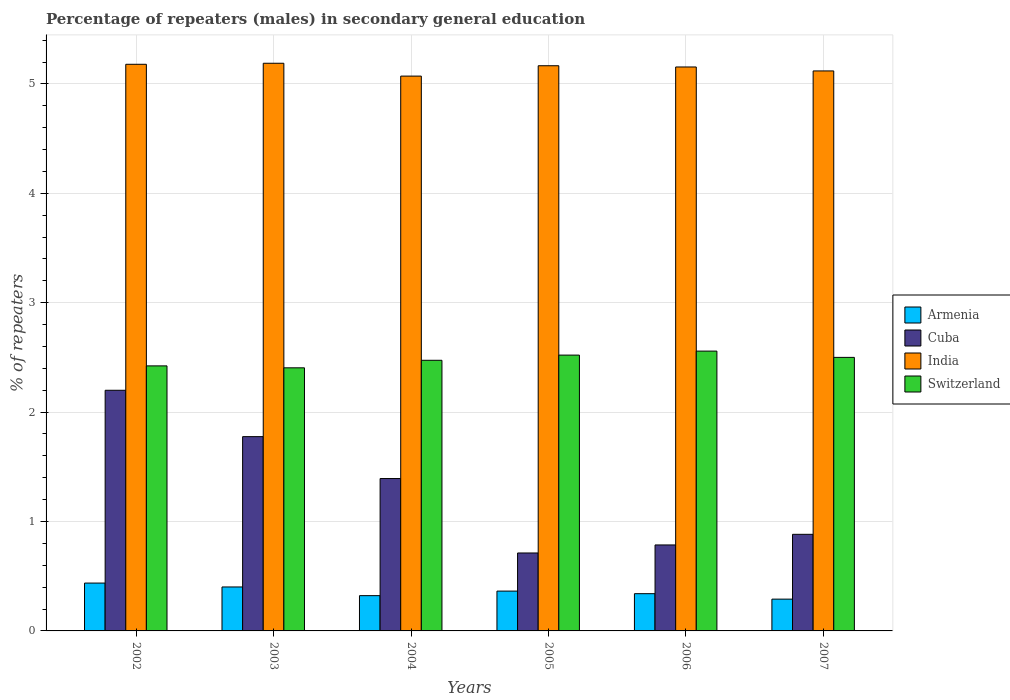Are the number of bars per tick equal to the number of legend labels?
Make the answer very short. Yes. How many bars are there on the 4th tick from the left?
Provide a succinct answer. 4. How many bars are there on the 3rd tick from the right?
Keep it short and to the point. 4. What is the label of the 2nd group of bars from the left?
Provide a short and direct response. 2003. In how many cases, is the number of bars for a given year not equal to the number of legend labels?
Your answer should be compact. 0. What is the percentage of male repeaters in India in 2004?
Keep it short and to the point. 5.07. Across all years, what is the maximum percentage of male repeaters in India?
Offer a terse response. 5.19. Across all years, what is the minimum percentage of male repeaters in Armenia?
Your answer should be compact. 0.29. In which year was the percentage of male repeaters in Cuba maximum?
Your answer should be compact. 2002. What is the total percentage of male repeaters in India in the graph?
Keep it short and to the point. 30.88. What is the difference between the percentage of male repeaters in India in 2002 and that in 2004?
Provide a succinct answer. 0.11. What is the difference between the percentage of male repeaters in India in 2003 and the percentage of male repeaters in Armenia in 2002?
Provide a succinct answer. 4.75. What is the average percentage of male repeaters in Cuba per year?
Provide a succinct answer. 1.29. In the year 2003, what is the difference between the percentage of male repeaters in Cuba and percentage of male repeaters in India?
Provide a succinct answer. -3.41. In how many years, is the percentage of male repeaters in Switzerland greater than 4.6 %?
Your answer should be compact. 0. What is the ratio of the percentage of male repeaters in Switzerland in 2005 to that in 2007?
Provide a succinct answer. 1.01. What is the difference between the highest and the second highest percentage of male repeaters in Armenia?
Your answer should be very brief. 0.04. What is the difference between the highest and the lowest percentage of male repeaters in India?
Your response must be concise. 0.12. Is the sum of the percentage of male repeaters in Cuba in 2004 and 2005 greater than the maximum percentage of male repeaters in India across all years?
Offer a very short reply. No. Is it the case that in every year, the sum of the percentage of male repeaters in Armenia and percentage of male repeaters in Switzerland is greater than the sum of percentage of male repeaters in India and percentage of male repeaters in Cuba?
Make the answer very short. No. What does the 2nd bar from the left in 2004 represents?
Your answer should be compact. Cuba. What does the 2nd bar from the right in 2002 represents?
Offer a terse response. India. How many bars are there?
Your answer should be very brief. 24. Are all the bars in the graph horizontal?
Your answer should be very brief. No. How many years are there in the graph?
Your answer should be very brief. 6. Does the graph contain any zero values?
Your answer should be compact. No. Does the graph contain grids?
Keep it short and to the point. Yes. How many legend labels are there?
Provide a succinct answer. 4. What is the title of the graph?
Offer a very short reply. Percentage of repeaters (males) in secondary general education. Does "Tunisia" appear as one of the legend labels in the graph?
Provide a short and direct response. No. What is the label or title of the X-axis?
Your response must be concise. Years. What is the label or title of the Y-axis?
Your answer should be very brief. % of repeaters. What is the % of repeaters in Armenia in 2002?
Keep it short and to the point. 0.44. What is the % of repeaters in Cuba in 2002?
Provide a short and direct response. 2.2. What is the % of repeaters of India in 2002?
Provide a succinct answer. 5.18. What is the % of repeaters in Switzerland in 2002?
Your answer should be compact. 2.42. What is the % of repeaters of Armenia in 2003?
Give a very brief answer. 0.4. What is the % of repeaters of Cuba in 2003?
Your response must be concise. 1.78. What is the % of repeaters of India in 2003?
Offer a terse response. 5.19. What is the % of repeaters of Switzerland in 2003?
Make the answer very short. 2.4. What is the % of repeaters in Armenia in 2004?
Make the answer very short. 0.32. What is the % of repeaters in Cuba in 2004?
Offer a terse response. 1.39. What is the % of repeaters of India in 2004?
Provide a succinct answer. 5.07. What is the % of repeaters in Switzerland in 2004?
Give a very brief answer. 2.47. What is the % of repeaters in Armenia in 2005?
Your answer should be very brief. 0.36. What is the % of repeaters of Cuba in 2005?
Give a very brief answer. 0.71. What is the % of repeaters in India in 2005?
Keep it short and to the point. 5.17. What is the % of repeaters in Switzerland in 2005?
Keep it short and to the point. 2.52. What is the % of repeaters in Armenia in 2006?
Your answer should be compact. 0.34. What is the % of repeaters in Cuba in 2006?
Ensure brevity in your answer.  0.79. What is the % of repeaters of India in 2006?
Your answer should be compact. 5.15. What is the % of repeaters in Switzerland in 2006?
Your answer should be compact. 2.56. What is the % of repeaters in Armenia in 2007?
Offer a very short reply. 0.29. What is the % of repeaters in Cuba in 2007?
Your answer should be very brief. 0.88. What is the % of repeaters in India in 2007?
Your answer should be very brief. 5.12. What is the % of repeaters of Switzerland in 2007?
Your answer should be compact. 2.5. Across all years, what is the maximum % of repeaters of Armenia?
Offer a very short reply. 0.44. Across all years, what is the maximum % of repeaters of Cuba?
Offer a very short reply. 2.2. Across all years, what is the maximum % of repeaters of India?
Your response must be concise. 5.19. Across all years, what is the maximum % of repeaters of Switzerland?
Give a very brief answer. 2.56. Across all years, what is the minimum % of repeaters in Armenia?
Offer a terse response. 0.29. Across all years, what is the minimum % of repeaters in Cuba?
Keep it short and to the point. 0.71. Across all years, what is the minimum % of repeaters in India?
Your response must be concise. 5.07. Across all years, what is the minimum % of repeaters of Switzerland?
Your response must be concise. 2.4. What is the total % of repeaters in Armenia in the graph?
Your response must be concise. 2.16. What is the total % of repeaters of Cuba in the graph?
Provide a succinct answer. 7.75. What is the total % of repeaters of India in the graph?
Offer a terse response. 30.88. What is the total % of repeaters in Switzerland in the graph?
Your answer should be compact. 14.88. What is the difference between the % of repeaters of Armenia in 2002 and that in 2003?
Provide a short and direct response. 0.04. What is the difference between the % of repeaters of Cuba in 2002 and that in 2003?
Your answer should be compact. 0.42. What is the difference between the % of repeaters in India in 2002 and that in 2003?
Offer a terse response. -0.01. What is the difference between the % of repeaters in Switzerland in 2002 and that in 2003?
Offer a terse response. 0.02. What is the difference between the % of repeaters in Armenia in 2002 and that in 2004?
Your answer should be compact. 0.11. What is the difference between the % of repeaters in Cuba in 2002 and that in 2004?
Ensure brevity in your answer.  0.81. What is the difference between the % of repeaters of India in 2002 and that in 2004?
Ensure brevity in your answer.  0.11. What is the difference between the % of repeaters in Switzerland in 2002 and that in 2004?
Make the answer very short. -0.05. What is the difference between the % of repeaters in Armenia in 2002 and that in 2005?
Keep it short and to the point. 0.07. What is the difference between the % of repeaters in Cuba in 2002 and that in 2005?
Give a very brief answer. 1.49. What is the difference between the % of repeaters in India in 2002 and that in 2005?
Provide a short and direct response. 0.01. What is the difference between the % of repeaters of Switzerland in 2002 and that in 2005?
Ensure brevity in your answer.  -0.1. What is the difference between the % of repeaters in Armenia in 2002 and that in 2006?
Offer a terse response. 0.1. What is the difference between the % of repeaters of Cuba in 2002 and that in 2006?
Ensure brevity in your answer.  1.41. What is the difference between the % of repeaters in India in 2002 and that in 2006?
Provide a succinct answer. 0.02. What is the difference between the % of repeaters of Switzerland in 2002 and that in 2006?
Provide a succinct answer. -0.14. What is the difference between the % of repeaters of Armenia in 2002 and that in 2007?
Your answer should be compact. 0.15. What is the difference between the % of repeaters in Cuba in 2002 and that in 2007?
Offer a terse response. 1.32. What is the difference between the % of repeaters in India in 2002 and that in 2007?
Make the answer very short. 0.06. What is the difference between the % of repeaters in Switzerland in 2002 and that in 2007?
Give a very brief answer. -0.08. What is the difference between the % of repeaters of Armenia in 2003 and that in 2004?
Make the answer very short. 0.08. What is the difference between the % of repeaters in Cuba in 2003 and that in 2004?
Your answer should be compact. 0.38. What is the difference between the % of repeaters of India in 2003 and that in 2004?
Your answer should be compact. 0.12. What is the difference between the % of repeaters of Switzerland in 2003 and that in 2004?
Offer a very short reply. -0.07. What is the difference between the % of repeaters in Armenia in 2003 and that in 2005?
Your answer should be compact. 0.04. What is the difference between the % of repeaters in Cuba in 2003 and that in 2005?
Give a very brief answer. 1.06. What is the difference between the % of repeaters in India in 2003 and that in 2005?
Offer a terse response. 0.02. What is the difference between the % of repeaters of Switzerland in 2003 and that in 2005?
Keep it short and to the point. -0.12. What is the difference between the % of repeaters in Armenia in 2003 and that in 2006?
Keep it short and to the point. 0.06. What is the difference between the % of repeaters of India in 2003 and that in 2006?
Ensure brevity in your answer.  0.03. What is the difference between the % of repeaters in Switzerland in 2003 and that in 2006?
Offer a terse response. -0.15. What is the difference between the % of repeaters of Armenia in 2003 and that in 2007?
Your response must be concise. 0.11. What is the difference between the % of repeaters of Cuba in 2003 and that in 2007?
Your answer should be very brief. 0.89. What is the difference between the % of repeaters of India in 2003 and that in 2007?
Offer a very short reply. 0.07. What is the difference between the % of repeaters in Switzerland in 2003 and that in 2007?
Offer a very short reply. -0.1. What is the difference between the % of repeaters in Armenia in 2004 and that in 2005?
Offer a terse response. -0.04. What is the difference between the % of repeaters in Cuba in 2004 and that in 2005?
Provide a short and direct response. 0.68. What is the difference between the % of repeaters in India in 2004 and that in 2005?
Make the answer very short. -0.09. What is the difference between the % of repeaters of Switzerland in 2004 and that in 2005?
Give a very brief answer. -0.05. What is the difference between the % of repeaters in Armenia in 2004 and that in 2006?
Ensure brevity in your answer.  -0.02. What is the difference between the % of repeaters of Cuba in 2004 and that in 2006?
Your response must be concise. 0.61. What is the difference between the % of repeaters of India in 2004 and that in 2006?
Your answer should be compact. -0.08. What is the difference between the % of repeaters in Switzerland in 2004 and that in 2006?
Keep it short and to the point. -0.08. What is the difference between the % of repeaters in Armenia in 2004 and that in 2007?
Ensure brevity in your answer.  0.03. What is the difference between the % of repeaters in Cuba in 2004 and that in 2007?
Provide a short and direct response. 0.51. What is the difference between the % of repeaters of India in 2004 and that in 2007?
Offer a very short reply. -0.05. What is the difference between the % of repeaters of Switzerland in 2004 and that in 2007?
Offer a very short reply. -0.03. What is the difference between the % of repeaters in Armenia in 2005 and that in 2006?
Offer a very short reply. 0.02. What is the difference between the % of repeaters of Cuba in 2005 and that in 2006?
Provide a short and direct response. -0.07. What is the difference between the % of repeaters in India in 2005 and that in 2006?
Your answer should be very brief. 0.01. What is the difference between the % of repeaters of Switzerland in 2005 and that in 2006?
Your answer should be compact. -0.04. What is the difference between the % of repeaters in Armenia in 2005 and that in 2007?
Give a very brief answer. 0.07. What is the difference between the % of repeaters in Cuba in 2005 and that in 2007?
Your answer should be very brief. -0.17. What is the difference between the % of repeaters in India in 2005 and that in 2007?
Your answer should be compact. 0.05. What is the difference between the % of repeaters of Switzerland in 2005 and that in 2007?
Your response must be concise. 0.02. What is the difference between the % of repeaters in Armenia in 2006 and that in 2007?
Offer a terse response. 0.05. What is the difference between the % of repeaters in Cuba in 2006 and that in 2007?
Keep it short and to the point. -0.1. What is the difference between the % of repeaters in India in 2006 and that in 2007?
Offer a terse response. 0.04. What is the difference between the % of repeaters of Switzerland in 2006 and that in 2007?
Give a very brief answer. 0.06. What is the difference between the % of repeaters in Armenia in 2002 and the % of repeaters in Cuba in 2003?
Offer a very short reply. -1.34. What is the difference between the % of repeaters of Armenia in 2002 and the % of repeaters of India in 2003?
Provide a short and direct response. -4.75. What is the difference between the % of repeaters of Armenia in 2002 and the % of repeaters of Switzerland in 2003?
Offer a very short reply. -1.97. What is the difference between the % of repeaters of Cuba in 2002 and the % of repeaters of India in 2003?
Offer a terse response. -2.99. What is the difference between the % of repeaters of Cuba in 2002 and the % of repeaters of Switzerland in 2003?
Offer a terse response. -0.21. What is the difference between the % of repeaters of India in 2002 and the % of repeaters of Switzerland in 2003?
Your answer should be compact. 2.77. What is the difference between the % of repeaters in Armenia in 2002 and the % of repeaters in Cuba in 2004?
Offer a terse response. -0.96. What is the difference between the % of repeaters in Armenia in 2002 and the % of repeaters in India in 2004?
Offer a very short reply. -4.63. What is the difference between the % of repeaters of Armenia in 2002 and the % of repeaters of Switzerland in 2004?
Your answer should be very brief. -2.04. What is the difference between the % of repeaters in Cuba in 2002 and the % of repeaters in India in 2004?
Offer a very short reply. -2.87. What is the difference between the % of repeaters of Cuba in 2002 and the % of repeaters of Switzerland in 2004?
Ensure brevity in your answer.  -0.27. What is the difference between the % of repeaters in India in 2002 and the % of repeaters in Switzerland in 2004?
Provide a succinct answer. 2.71. What is the difference between the % of repeaters in Armenia in 2002 and the % of repeaters in Cuba in 2005?
Offer a terse response. -0.28. What is the difference between the % of repeaters in Armenia in 2002 and the % of repeaters in India in 2005?
Provide a short and direct response. -4.73. What is the difference between the % of repeaters in Armenia in 2002 and the % of repeaters in Switzerland in 2005?
Your response must be concise. -2.08. What is the difference between the % of repeaters in Cuba in 2002 and the % of repeaters in India in 2005?
Offer a terse response. -2.97. What is the difference between the % of repeaters of Cuba in 2002 and the % of repeaters of Switzerland in 2005?
Offer a terse response. -0.32. What is the difference between the % of repeaters of India in 2002 and the % of repeaters of Switzerland in 2005?
Your answer should be compact. 2.66. What is the difference between the % of repeaters in Armenia in 2002 and the % of repeaters in Cuba in 2006?
Make the answer very short. -0.35. What is the difference between the % of repeaters in Armenia in 2002 and the % of repeaters in India in 2006?
Give a very brief answer. -4.72. What is the difference between the % of repeaters in Armenia in 2002 and the % of repeaters in Switzerland in 2006?
Give a very brief answer. -2.12. What is the difference between the % of repeaters in Cuba in 2002 and the % of repeaters in India in 2006?
Your answer should be very brief. -2.96. What is the difference between the % of repeaters in Cuba in 2002 and the % of repeaters in Switzerland in 2006?
Give a very brief answer. -0.36. What is the difference between the % of repeaters in India in 2002 and the % of repeaters in Switzerland in 2006?
Ensure brevity in your answer.  2.62. What is the difference between the % of repeaters of Armenia in 2002 and the % of repeaters of Cuba in 2007?
Offer a very short reply. -0.45. What is the difference between the % of repeaters of Armenia in 2002 and the % of repeaters of India in 2007?
Offer a very short reply. -4.68. What is the difference between the % of repeaters in Armenia in 2002 and the % of repeaters in Switzerland in 2007?
Offer a very short reply. -2.06. What is the difference between the % of repeaters of Cuba in 2002 and the % of repeaters of India in 2007?
Give a very brief answer. -2.92. What is the difference between the % of repeaters in Cuba in 2002 and the % of repeaters in Switzerland in 2007?
Provide a succinct answer. -0.3. What is the difference between the % of repeaters of India in 2002 and the % of repeaters of Switzerland in 2007?
Offer a very short reply. 2.68. What is the difference between the % of repeaters of Armenia in 2003 and the % of repeaters of Cuba in 2004?
Your answer should be very brief. -0.99. What is the difference between the % of repeaters of Armenia in 2003 and the % of repeaters of India in 2004?
Keep it short and to the point. -4.67. What is the difference between the % of repeaters of Armenia in 2003 and the % of repeaters of Switzerland in 2004?
Provide a short and direct response. -2.07. What is the difference between the % of repeaters of Cuba in 2003 and the % of repeaters of India in 2004?
Ensure brevity in your answer.  -3.3. What is the difference between the % of repeaters in Cuba in 2003 and the % of repeaters in Switzerland in 2004?
Provide a short and direct response. -0.7. What is the difference between the % of repeaters of India in 2003 and the % of repeaters of Switzerland in 2004?
Your response must be concise. 2.71. What is the difference between the % of repeaters in Armenia in 2003 and the % of repeaters in Cuba in 2005?
Your answer should be compact. -0.31. What is the difference between the % of repeaters of Armenia in 2003 and the % of repeaters of India in 2005?
Your answer should be compact. -4.76. What is the difference between the % of repeaters of Armenia in 2003 and the % of repeaters of Switzerland in 2005?
Keep it short and to the point. -2.12. What is the difference between the % of repeaters in Cuba in 2003 and the % of repeaters in India in 2005?
Your answer should be compact. -3.39. What is the difference between the % of repeaters in Cuba in 2003 and the % of repeaters in Switzerland in 2005?
Your response must be concise. -0.75. What is the difference between the % of repeaters in India in 2003 and the % of repeaters in Switzerland in 2005?
Your answer should be very brief. 2.67. What is the difference between the % of repeaters of Armenia in 2003 and the % of repeaters of Cuba in 2006?
Make the answer very short. -0.38. What is the difference between the % of repeaters in Armenia in 2003 and the % of repeaters in India in 2006?
Give a very brief answer. -4.75. What is the difference between the % of repeaters of Armenia in 2003 and the % of repeaters of Switzerland in 2006?
Your answer should be very brief. -2.16. What is the difference between the % of repeaters in Cuba in 2003 and the % of repeaters in India in 2006?
Your answer should be very brief. -3.38. What is the difference between the % of repeaters in Cuba in 2003 and the % of repeaters in Switzerland in 2006?
Give a very brief answer. -0.78. What is the difference between the % of repeaters of India in 2003 and the % of repeaters of Switzerland in 2006?
Ensure brevity in your answer.  2.63. What is the difference between the % of repeaters of Armenia in 2003 and the % of repeaters of Cuba in 2007?
Your answer should be very brief. -0.48. What is the difference between the % of repeaters of Armenia in 2003 and the % of repeaters of India in 2007?
Keep it short and to the point. -4.72. What is the difference between the % of repeaters in Armenia in 2003 and the % of repeaters in Switzerland in 2007?
Offer a very short reply. -2.1. What is the difference between the % of repeaters in Cuba in 2003 and the % of repeaters in India in 2007?
Keep it short and to the point. -3.34. What is the difference between the % of repeaters of Cuba in 2003 and the % of repeaters of Switzerland in 2007?
Your answer should be very brief. -0.72. What is the difference between the % of repeaters in India in 2003 and the % of repeaters in Switzerland in 2007?
Ensure brevity in your answer.  2.69. What is the difference between the % of repeaters in Armenia in 2004 and the % of repeaters in Cuba in 2005?
Provide a short and direct response. -0.39. What is the difference between the % of repeaters of Armenia in 2004 and the % of repeaters of India in 2005?
Your answer should be compact. -4.84. What is the difference between the % of repeaters of Armenia in 2004 and the % of repeaters of Switzerland in 2005?
Offer a terse response. -2.2. What is the difference between the % of repeaters in Cuba in 2004 and the % of repeaters in India in 2005?
Make the answer very short. -3.77. What is the difference between the % of repeaters of Cuba in 2004 and the % of repeaters of Switzerland in 2005?
Give a very brief answer. -1.13. What is the difference between the % of repeaters of India in 2004 and the % of repeaters of Switzerland in 2005?
Offer a very short reply. 2.55. What is the difference between the % of repeaters in Armenia in 2004 and the % of repeaters in Cuba in 2006?
Ensure brevity in your answer.  -0.46. What is the difference between the % of repeaters in Armenia in 2004 and the % of repeaters in India in 2006?
Provide a short and direct response. -4.83. What is the difference between the % of repeaters in Armenia in 2004 and the % of repeaters in Switzerland in 2006?
Your response must be concise. -2.24. What is the difference between the % of repeaters in Cuba in 2004 and the % of repeaters in India in 2006?
Provide a succinct answer. -3.76. What is the difference between the % of repeaters in Cuba in 2004 and the % of repeaters in Switzerland in 2006?
Keep it short and to the point. -1.16. What is the difference between the % of repeaters in India in 2004 and the % of repeaters in Switzerland in 2006?
Give a very brief answer. 2.51. What is the difference between the % of repeaters in Armenia in 2004 and the % of repeaters in Cuba in 2007?
Make the answer very short. -0.56. What is the difference between the % of repeaters of Armenia in 2004 and the % of repeaters of India in 2007?
Offer a terse response. -4.8. What is the difference between the % of repeaters in Armenia in 2004 and the % of repeaters in Switzerland in 2007?
Your answer should be very brief. -2.18. What is the difference between the % of repeaters of Cuba in 2004 and the % of repeaters of India in 2007?
Make the answer very short. -3.73. What is the difference between the % of repeaters in Cuba in 2004 and the % of repeaters in Switzerland in 2007?
Give a very brief answer. -1.11. What is the difference between the % of repeaters of India in 2004 and the % of repeaters of Switzerland in 2007?
Offer a terse response. 2.57. What is the difference between the % of repeaters of Armenia in 2005 and the % of repeaters of Cuba in 2006?
Keep it short and to the point. -0.42. What is the difference between the % of repeaters in Armenia in 2005 and the % of repeaters in India in 2006?
Offer a terse response. -4.79. What is the difference between the % of repeaters of Armenia in 2005 and the % of repeaters of Switzerland in 2006?
Your response must be concise. -2.19. What is the difference between the % of repeaters of Cuba in 2005 and the % of repeaters of India in 2006?
Make the answer very short. -4.44. What is the difference between the % of repeaters of Cuba in 2005 and the % of repeaters of Switzerland in 2006?
Provide a succinct answer. -1.85. What is the difference between the % of repeaters in India in 2005 and the % of repeaters in Switzerland in 2006?
Give a very brief answer. 2.61. What is the difference between the % of repeaters of Armenia in 2005 and the % of repeaters of Cuba in 2007?
Your answer should be very brief. -0.52. What is the difference between the % of repeaters of Armenia in 2005 and the % of repeaters of India in 2007?
Provide a short and direct response. -4.75. What is the difference between the % of repeaters of Armenia in 2005 and the % of repeaters of Switzerland in 2007?
Ensure brevity in your answer.  -2.14. What is the difference between the % of repeaters in Cuba in 2005 and the % of repeaters in India in 2007?
Your answer should be compact. -4.41. What is the difference between the % of repeaters in Cuba in 2005 and the % of repeaters in Switzerland in 2007?
Make the answer very short. -1.79. What is the difference between the % of repeaters in India in 2005 and the % of repeaters in Switzerland in 2007?
Provide a succinct answer. 2.67. What is the difference between the % of repeaters in Armenia in 2006 and the % of repeaters in Cuba in 2007?
Offer a terse response. -0.54. What is the difference between the % of repeaters of Armenia in 2006 and the % of repeaters of India in 2007?
Your answer should be very brief. -4.78. What is the difference between the % of repeaters of Armenia in 2006 and the % of repeaters of Switzerland in 2007?
Keep it short and to the point. -2.16. What is the difference between the % of repeaters in Cuba in 2006 and the % of repeaters in India in 2007?
Your answer should be very brief. -4.33. What is the difference between the % of repeaters of Cuba in 2006 and the % of repeaters of Switzerland in 2007?
Your response must be concise. -1.71. What is the difference between the % of repeaters of India in 2006 and the % of repeaters of Switzerland in 2007?
Provide a short and direct response. 2.65. What is the average % of repeaters of Armenia per year?
Provide a short and direct response. 0.36. What is the average % of repeaters in Cuba per year?
Your answer should be compact. 1.29. What is the average % of repeaters of India per year?
Give a very brief answer. 5.15. What is the average % of repeaters of Switzerland per year?
Keep it short and to the point. 2.48. In the year 2002, what is the difference between the % of repeaters of Armenia and % of repeaters of Cuba?
Give a very brief answer. -1.76. In the year 2002, what is the difference between the % of repeaters in Armenia and % of repeaters in India?
Offer a very short reply. -4.74. In the year 2002, what is the difference between the % of repeaters of Armenia and % of repeaters of Switzerland?
Your response must be concise. -1.99. In the year 2002, what is the difference between the % of repeaters in Cuba and % of repeaters in India?
Your answer should be compact. -2.98. In the year 2002, what is the difference between the % of repeaters of Cuba and % of repeaters of Switzerland?
Make the answer very short. -0.22. In the year 2002, what is the difference between the % of repeaters of India and % of repeaters of Switzerland?
Ensure brevity in your answer.  2.76. In the year 2003, what is the difference between the % of repeaters of Armenia and % of repeaters of Cuba?
Ensure brevity in your answer.  -1.37. In the year 2003, what is the difference between the % of repeaters in Armenia and % of repeaters in India?
Your answer should be compact. -4.79. In the year 2003, what is the difference between the % of repeaters of Armenia and % of repeaters of Switzerland?
Provide a succinct answer. -2. In the year 2003, what is the difference between the % of repeaters of Cuba and % of repeaters of India?
Provide a succinct answer. -3.41. In the year 2003, what is the difference between the % of repeaters in Cuba and % of repeaters in Switzerland?
Give a very brief answer. -0.63. In the year 2003, what is the difference between the % of repeaters in India and % of repeaters in Switzerland?
Your answer should be compact. 2.78. In the year 2004, what is the difference between the % of repeaters of Armenia and % of repeaters of Cuba?
Your response must be concise. -1.07. In the year 2004, what is the difference between the % of repeaters of Armenia and % of repeaters of India?
Make the answer very short. -4.75. In the year 2004, what is the difference between the % of repeaters of Armenia and % of repeaters of Switzerland?
Give a very brief answer. -2.15. In the year 2004, what is the difference between the % of repeaters of Cuba and % of repeaters of India?
Offer a very short reply. -3.68. In the year 2004, what is the difference between the % of repeaters of Cuba and % of repeaters of Switzerland?
Give a very brief answer. -1.08. In the year 2004, what is the difference between the % of repeaters in India and % of repeaters in Switzerland?
Offer a very short reply. 2.6. In the year 2005, what is the difference between the % of repeaters in Armenia and % of repeaters in Cuba?
Provide a succinct answer. -0.35. In the year 2005, what is the difference between the % of repeaters in Armenia and % of repeaters in India?
Provide a succinct answer. -4.8. In the year 2005, what is the difference between the % of repeaters of Armenia and % of repeaters of Switzerland?
Your answer should be compact. -2.16. In the year 2005, what is the difference between the % of repeaters of Cuba and % of repeaters of India?
Ensure brevity in your answer.  -4.45. In the year 2005, what is the difference between the % of repeaters in Cuba and % of repeaters in Switzerland?
Your answer should be compact. -1.81. In the year 2005, what is the difference between the % of repeaters in India and % of repeaters in Switzerland?
Your response must be concise. 2.64. In the year 2006, what is the difference between the % of repeaters of Armenia and % of repeaters of Cuba?
Offer a terse response. -0.45. In the year 2006, what is the difference between the % of repeaters of Armenia and % of repeaters of India?
Your answer should be compact. -4.81. In the year 2006, what is the difference between the % of repeaters of Armenia and % of repeaters of Switzerland?
Provide a succinct answer. -2.22. In the year 2006, what is the difference between the % of repeaters of Cuba and % of repeaters of India?
Make the answer very short. -4.37. In the year 2006, what is the difference between the % of repeaters in Cuba and % of repeaters in Switzerland?
Ensure brevity in your answer.  -1.77. In the year 2006, what is the difference between the % of repeaters in India and % of repeaters in Switzerland?
Provide a succinct answer. 2.6. In the year 2007, what is the difference between the % of repeaters in Armenia and % of repeaters in Cuba?
Provide a short and direct response. -0.59. In the year 2007, what is the difference between the % of repeaters of Armenia and % of repeaters of India?
Ensure brevity in your answer.  -4.83. In the year 2007, what is the difference between the % of repeaters of Armenia and % of repeaters of Switzerland?
Your answer should be compact. -2.21. In the year 2007, what is the difference between the % of repeaters in Cuba and % of repeaters in India?
Provide a short and direct response. -4.24. In the year 2007, what is the difference between the % of repeaters of Cuba and % of repeaters of Switzerland?
Your answer should be compact. -1.62. In the year 2007, what is the difference between the % of repeaters in India and % of repeaters in Switzerland?
Give a very brief answer. 2.62. What is the ratio of the % of repeaters in Armenia in 2002 to that in 2003?
Your answer should be compact. 1.09. What is the ratio of the % of repeaters in Cuba in 2002 to that in 2003?
Offer a terse response. 1.24. What is the ratio of the % of repeaters of India in 2002 to that in 2003?
Your response must be concise. 1. What is the ratio of the % of repeaters in Switzerland in 2002 to that in 2003?
Offer a terse response. 1.01. What is the ratio of the % of repeaters in Armenia in 2002 to that in 2004?
Your response must be concise. 1.36. What is the ratio of the % of repeaters in Cuba in 2002 to that in 2004?
Make the answer very short. 1.58. What is the ratio of the % of repeaters in India in 2002 to that in 2004?
Your answer should be very brief. 1.02. What is the ratio of the % of repeaters of Switzerland in 2002 to that in 2004?
Your answer should be compact. 0.98. What is the ratio of the % of repeaters in Armenia in 2002 to that in 2005?
Offer a very short reply. 1.2. What is the ratio of the % of repeaters in Cuba in 2002 to that in 2005?
Provide a succinct answer. 3.09. What is the ratio of the % of repeaters in India in 2002 to that in 2005?
Offer a terse response. 1. What is the ratio of the % of repeaters in Switzerland in 2002 to that in 2005?
Offer a terse response. 0.96. What is the ratio of the % of repeaters in Armenia in 2002 to that in 2006?
Keep it short and to the point. 1.28. What is the ratio of the % of repeaters of Cuba in 2002 to that in 2006?
Keep it short and to the point. 2.8. What is the ratio of the % of repeaters of India in 2002 to that in 2006?
Keep it short and to the point. 1. What is the ratio of the % of repeaters of Switzerland in 2002 to that in 2006?
Your answer should be very brief. 0.95. What is the ratio of the % of repeaters in Armenia in 2002 to that in 2007?
Your answer should be compact. 1.51. What is the ratio of the % of repeaters of Cuba in 2002 to that in 2007?
Make the answer very short. 2.49. What is the ratio of the % of repeaters in India in 2002 to that in 2007?
Your answer should be compact. 1.01. What is the ratio of the % of repeaters of Switzerland in 2002 to that in 2007?
Provide a succinct answer. 0.97. What is the ratio of the % of repeaters in Armenia in 2003 to that in 2004?
Your answer should be compact. 1.25. What is the ratio of the % of repeaters in Cuba in 2003 to that in 2004?
Your response must be concise. 1.27. What is the ratio of the % of repeaters in India in 2003 to that in 2004?
Your response must be concise. 1.02. What is the ratio of the % of repeaters in Switzerland in 2003 to that in 2004?
Offer a terse response. 0.97. What is the ratio of the % of repeaters in Armenia in 2003 to that in 2005?
Your answer should be very brief. 1.1. What is the ratio of the % of repeaters in Cuba in 2003 to that in 2005?
Ensure brevity in your answer.  2.49. What is the ratio of the % of repeaters of Switzerland in 2003 to that in 2005?
Offer a terse response. 0.95. What is the ratio of the % of repeaters of Armenia in 2003 to that in 2006?
Offer a very short reply. 1.18. What is the ratio of the % of repeaters in Cuba in 2003 to that in 2006?
Keep it short and to the point. 2.26. What is the ratio of the % of repeaters in India in 2003 to that in 2006?
Offer a very short reply. 1.01. What is the ratio of the % of repeaters of Switzerland in 2003 to that in 2006?
Your answer should be compact. 0.94. What is the ratio of the % of repeaters of Armenia in 2003 to that in 2007?
Provide a succinct answer. 1.38. What is the ratio of the % of repeaters in Cuba in 2003 to that in 2007?
Provide a succinct answer. 2.01. What is the ratio of the % of repeaters of India in 2003 to that in 2007?
Provide a succinct answer. 1.01. What is the ratio of the % of repeaters in Switzerland in 2003 to that in 2007?
Your answer should be compact. 0.96. What is the ratio of the % of repeaters of Armenia in 2004 to that in 2005?
Your answer should be compact. 0.89. What is the ratio of the % of repeaters of Cuba in 2004 to that in 2005?
Provide a succinct answer. 1.96. What is the ratio of the % of repeaters of India in 2004 to that in 2005?
Provide a short and direct response. 0.98. What is the ratio of the % of repeaters in Switzerland in 2004 to that in 2005?
Ensure brevity in your answer.  0.98. What is the ratio of the % of repeaters of Armenia in 2004 to that in 2006?
Offer a terse response. 0.95. What is the ratio of the % of repeaters in Cuba in 2004 to that in 2006?
Your response must be concise. 1.77. What is the ratio of the % of repeaters in India in 2004 to that in 2006?
Give a very brief answer. 0.98. What is the ratio of the % of repeaters in Switzerland in 2004 to that in 2006?
Offer a terse response. 0.97. What is the ratio of the % of repeaters of Armenia in 2004 to that in 2007?
Your answer should be compact. 1.11. What is the ratio of the % of repeaters of Cuba in 2004 to that in 2007?
Offer a terse response. 1.58. What is the ratio of the % of repeaters in India in 2004 to that in 2007?
Give a very brief answer. 0.99. What is the ratio of the % of repeaters in Switzerland in 2004 to that in 2007?
Provide a succinct answer. 0.99. What is the ratio of the % of repeaters of Armenia in 2005 to that in 2006?
Your answer should be compact. 1.07. What is the ratio of the % of repeaters of Cuba in 2005 to that in 2006?
Your answer should be compact. 0.91. What is the ratio of the % of repeaters in India in 2005 to that in 2006?
Make the answer very short. 1. What is the ratio of the % of repeaters in Switzerland in 2005 to that in 2006?
Your response must be concise. 0.99. What is the ratio of the % of repeaters in Armenia in 2005 to that in 2007?
Keep it short and to the point. 1.25. What is the ratio of the % of repeaters of Cuba in 2005 to that in 2007?
Your answer should be very brief. 0.81. What is the ratio of the % of repeaters in India in 2005 to that in 2007?
Give a very brief answer. 1.01. What is the ratio of the % of repeaters in Switzerland in 2005 to that in 2007?
Ensure brevity in your answer.  1.01. What is the ratio of the % of repeaters of Armenia in 2006 to that in 2007?
Give a very brief answer. 1.17. What is the ratio of the % of repeaters in Cuba in 2006 to that in 2007?
Your response must be concise. 0.89. What is the ratio of the % of repeaters in India in 2006 to that in 2007?
Provide a succinct answer. 1.01. What is the ratio of the % of repeaters of Switzerland in 2006 to that in 2007?
Make the answer very short. 1.02. What is the difference between the highest and the second highest % of repeaters of Armenia?
Your response must be concise. 0.04. What is the difference between the highest and the second highest % of repeaters in Cuba?
Your answer should be very brief. 0.42. What is the difference between the highest and the second highest % of repeaters of India?
Give a very brief answer. 0.01. What is the difference between the highest and the second highest % of repeaters in Switzerland?
Offer a terse response. 0.04. What is the difference between the highest and the lowest % of repeaters in Armenia?
Ensure brevity in your answer.  0.15. What is the difference between the highest and the lowest % of repeaters of Cuba?
Keep it short and to the point. 1.49. What is the difference between the highest and the lowest % of repeaters of India?
Keep it short and to the point. 0.12. What is the difference between the highest and the lowest % of repeaters of Switzerland?
Provide a short and direct response. 0.15. 